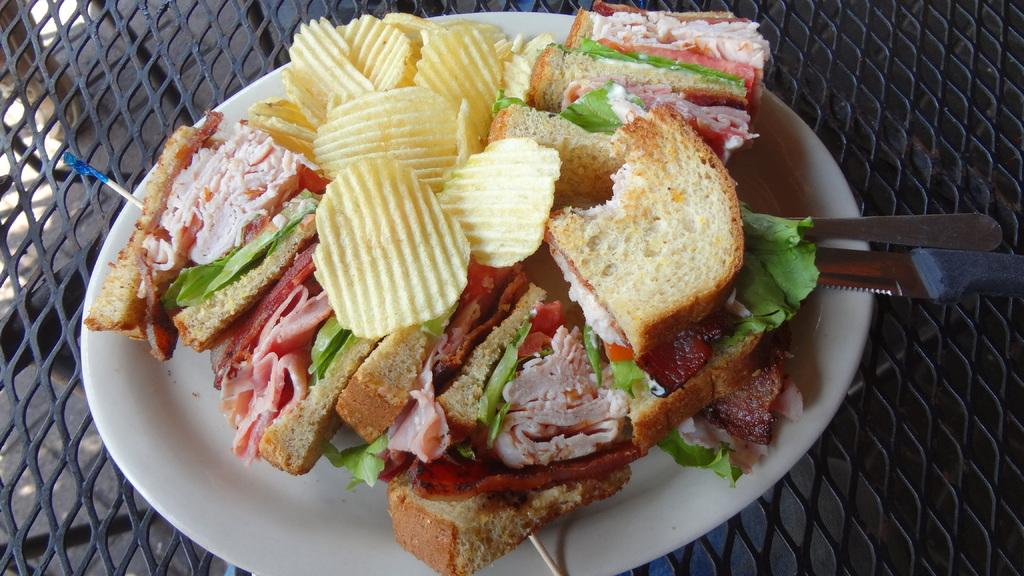What is on the plate that is visible in the image? There is a plate with food in the image. What utensils are visible in the image? There is a spoon and a knife in the image. On what surface are the plate and utensils placed? The objects are on a table-like surface in the image. What type of decision can be seen being made in the image? There is no decision-making process visible in the image; it only shows a plate with food, a spoon, and a knife on a table-like surface. 